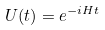<formula> <loc_0><loc_0><loc_500><loc_500>U ( t ) = e ^ { - i H t }</formula> 